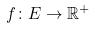<formula> <loc_0><loc_0><loc_500><loc_500>f \colon E \rightarrow \mathbb { R } ^ { + }</formula> 